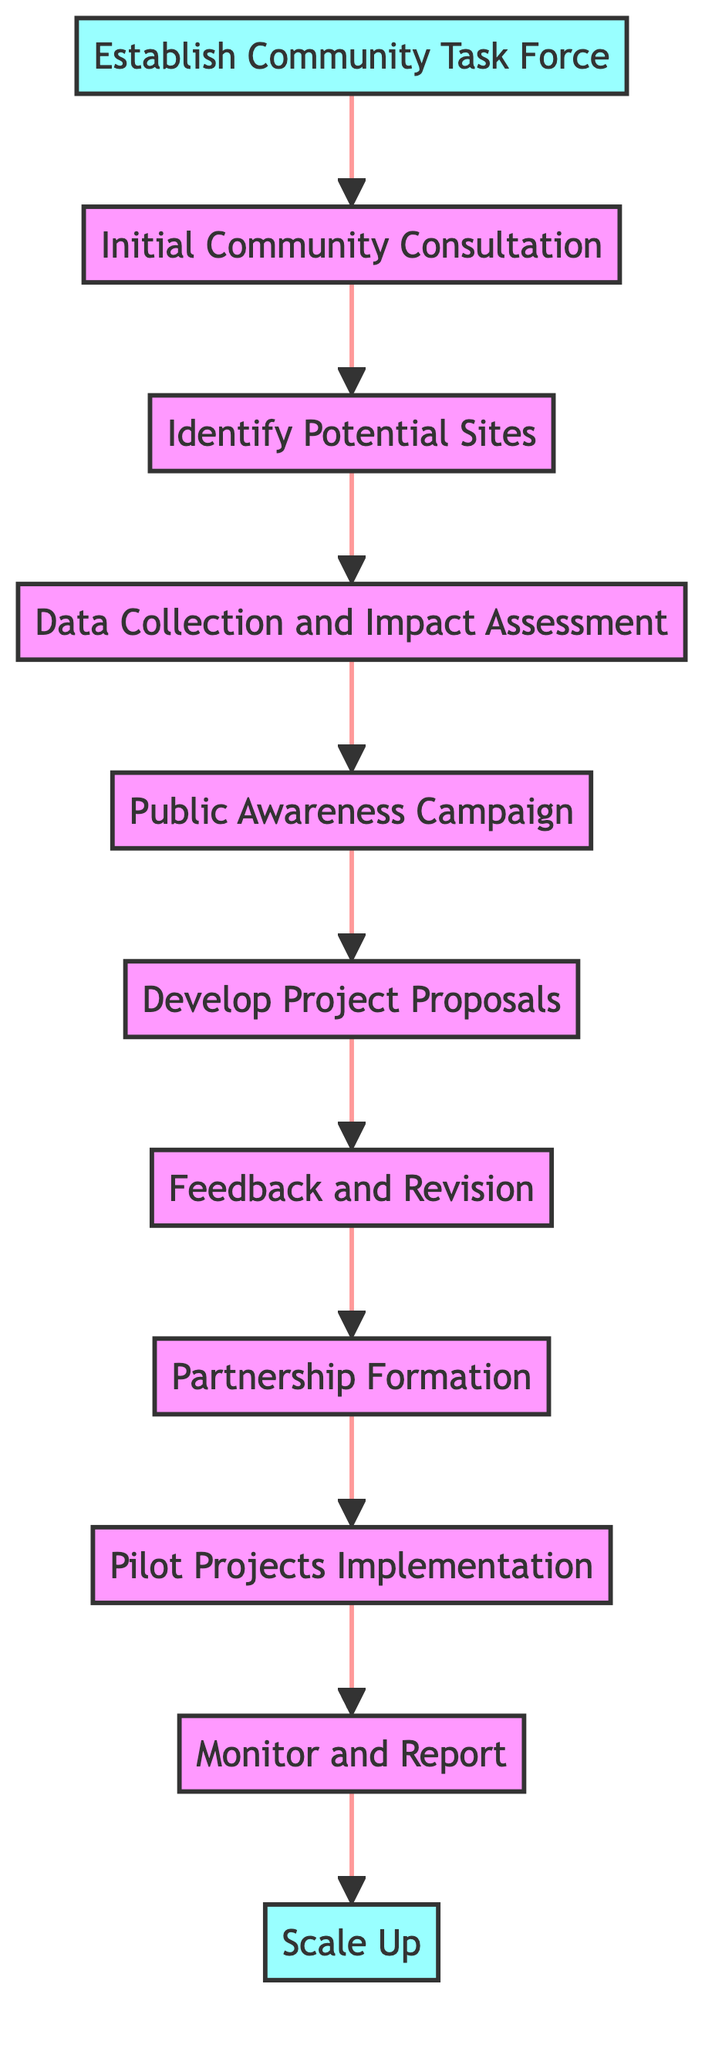What is the first step in the Community Engagement Strategy? The first step, indicated in the diagram, is to establish a community task force, which is labeled as node 1.
Answer: Establish Community Task Force How many total nodes are present in the flow chart? By counting all the individual steps from node 1 to node 11 inclusive, there are a total of 11 nodes in the chart.
Answer: 11 Which node follows the 'Data Collection and Impact Assessment'? In the flow of the chart, the node that comes after 'Data Collection and Impact Assessment' (node 4) is the 'Public Awareness Campaign' (node 5).
Answer: Public Awareness Campaign What is the last step after 'Monitor and Report'? The final step in the process, following 'Monitor and Report' (node 10), is 'Scale Up' (node 11).
Answer: Scale Up How many dependencies does 'Initial Community Consultation' have? The 'Initial Community Consultation' (node 2) has one dependency, which is the established community task force (node 1).
Answer: 1 Which step comes before 'Partnership Formation'? The diagram indicates that 'Feedback and Revision' (node 7) is the step that comes directly before 'Partnership Formation' (node 8).
Answer: Feedback and Revision Is 'Pilot Projects Implementation' a milestone step? In the diagram, 'Pilot Projects Implementation' (node 9) is not marked as a milestone step; only 'Establish Community Task Force' and 'Scale Up' are designated as milestones.
Answer: No Which steps include community consultations? The steps that involve community consultations are 'Initial Community Consultation' (node 2) and 'Feedback and Revision' (node 7), as both incorporate community input.
Answer: Initial Community Consultation, Feedback and Revision What is the last action in the process outlined by the flowchart? The last action specified in the flowchart process after all prior steps is to 'Scale Up' (node 11) renewable energy initiatives.
Answer: Scale Up 